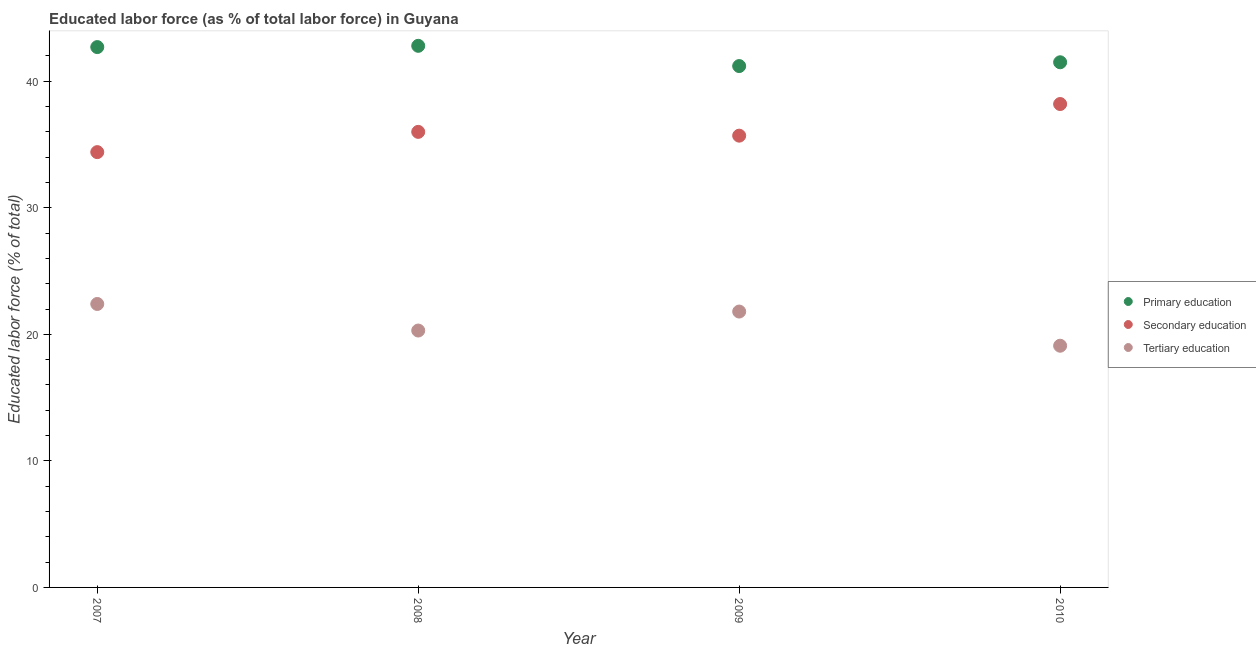What is the percentage of labor force who received secondary education in 2010?
Keep it short and to the point. 38.2. Across all years, what is the maximum percentage of labor force who received primary education?
Offer a terse response. 42.8. Across all years, what is the minimum percentage of labor force who received secondary education?
Provide a short and direct response. 34.4. In which year was the percentage of labor force who received secondary education minimum?
Offer a terse response. 2007. What is the total percentage of labor force who received primary education in the graph?
Your answer should be compact. 168.2. What is the difference between the percentage of labor force who received primary education in 2007 and that in 2010?
Your answer should be very brief. 1.2. What is the average percentage of labor force who received tertiary education per year?
Ensure brevity in your answer.  20.9. In the year 2009, what is the difference between the percentage of labor force who received tertiary education and percentage of labor force who received secondary education?
Your answer should be compact. -13.9. In how many years, is the percentage of labor force who received tertiary education greater than 14 %?
Your answer should be very brief. 4. What is the ratio of the percentage of labor force who received secondary education in 2008 to that in 2010?
Offer a very short reply. 0.94. Is the difference between the percentage of labor force who received secondary education in 2008 and 2009 greater than the difference between the percentage of labor force who received primary education in 2008 and 2009?
Offer a terse response. No. What is the difference between the highest and the second highest percentage of labor force who received primary education?
Your response must be concise. 0.1. What is the difference between the highest and the lowest percentage of labor force who received secondary education?
Offer a very short reply. 3.8. Is the sum of the percentage of labor force who received primary education in 2008 and 2010 greater than the maximum percentage of labor force who received tertiary education across all years?
Your answer should be very brief. Yes. Is it the case that in every year, the sum of the percentage of labor force who received primary education and percentage of labor force who received secondary education is greater than the percentage of labor force who received tertiary education?
Provide a succinct answer. Yes. Is the percentage of labor force who received primary education strictly greater than the percentage of labor force who received tertiary education over the years?
Make the answer very short. Yes. How many dotlines are there?
Ensure brevity in your answer.  3. How many years are there in the graph?
Keep it short and to the point. 4. What is the difference between two consecutive major ticks on the Y-axis?
Ensure brevity in your answer.  10. How are the legend labels stacked?
Ensure brevity in your answer.  Vertical. What is the title of the graph?
Your response must be concise. Educated labor force (as % of total labor force) in Guyana. What is the label or title of the X-axis?
Provide a succinct answer. Year. What is the label or title of the Y-axis?
Provide a short and direct response. Educated labor force (% of total). What is the Educated labor force (% of total) in Primary education in 2007?
Your answer should be very brief. 42.7. What is the Educated labor force (% of total) in Secondary education in 2007?
Offer a terse response. 34.4. What is the Educated labor force (% of total) in Tertiary education in 2007?
Give a very brief answer. 22.4. What is the Educated labor force (% of total) in Primary education in 2008?
Your answer should be compact. 42.8. What is the Educated labor force (% of total) of Secondary education in 2008?
Provide a short and direct response. 36. What is the Educated labor force (% of total) in Tertiary education in 2008?
Ensure brevity in your answer.  20.3. What is the Educated labor force (% of total) of Primary education in 2009?
Your answer should be compact. 41.2. What is the Educated labor force (% of total) in Secondary education in 2009?
Offer a terse response. 35.7. What is the Educated labor force (% of total) of Tertiary education in 2009?
Provide a short and direct response. 21.8. What is the Educated labor force (% of total) of Primary education in 2010?
Offer a very short reply. 41.5. What is the Educated labor force (% of total) of Secondary education in 2010?
Your answer should be compact. 38.2. What is the Educated labor force (% of total) in Tertiary education in 2010?
Keep it short and to the point. 19.1. Across all years, what is the maximum Educated labor force (% of total) of Primary education?
Ensure brevity in your answer.  42.8. Across all years, what is the maximum Educated labor force (% of total) in Secondary education?
Offer a terse response. 38.2. Across all years, what is the maximum Educated labor force (% of total) in Tertiary education?
Offer a terse response. 22.4. Across all years, what is the minimum Educated labor force (% of total) in Primary education?
Offer a very short reply. 41.2. Across all years, what is the minimum Educated labor force (% of total) in Secondary education?
Offer a terse response. 34.4. Across all years, what is the minimum Educated labor force (% of total) in Tertiary education?
Your response must be concise. 19.1. What is the total Educated labor force (% of total) of Primary education in the graph?
Your answer should be compact. 168.2. What is the total Educated labor force (% of total) of Secondary education in the graph?
Provide a succinct answer. 144.3. What is the total Educated labor force (% of total) of Tertiary education in the graph?
Provide a succinct answer. 83.6. What is the difference between the Educated labor force (% of total) in Primary education in 2007 and that in 2008?
Offer a very short reply. -0.1. What is the difference between the Educated labor force (% of total) of Secondary education in 2007 and that in 2008?
Give a very brief answer. -1.6. What is the difference between the Educated labor force (% of total) in Tertiary education in 2007 and that in 2008?
Your answer should be compact. 2.1. What is the difference between the Educated labor force (% of total) of Primary education in 2007 and that in 2009?
Provide a succinct answer. 1.5. What is the difference between the Educated labor force (% of total) of Tertiary education in 2007 and that in 2009?
Give a very brief answer. 0.6. What is the difference between the Educated labor force (% of total) of Primary education in 2007 and that in 2010?
Keep it short and to the point. 1.2. What is the difference between the Educated labor force (% of total) in Tertiary education in 2007 and that in 2010?
Provide a short and direct response. 3.3. What is the difference between the Educated labor force (% of total) of Secondary education in 2008 and that in 2009?
Offer a terse response. 0.3. What is the difference between the Educated labor force (% of total) in Tertiary education in 2008 and that in 2009?
Provide a succinct answer. -1.5. What is the difference between the Educated labor force (% of total) of Primary education in 2008 and that in 2010?
Ensure brevity in your answer.  1.3. What is the difference between the Educated labor force (% of total) of Secondary education in 2008 and that in 2010?
Keep it short and to the point. -2.2. What is the difference between the Educated labor force (% of total) of Tertiary education in 2008 and that in 2010?
Your answer should be very brief. 1.2. What is the difference between the Educated labor force (% of total) in Primary education in 2009 and that in 2010?
Your answer should be compact. -0.3. What is the difference between the Educated labor force (% of total) of Primary education in 2007 and the Educated labor force (% of total) of Secondary education in 2008?
Keep it short and to the point. 6.7. What is the difference between the Educated labor force (% of total) in Primary education in 2007 and the Educated labor force (% of total) in Tertiary education in 2008?
Your answer should be compact. 22.4. What is the difference between the Educated labor force (% of total) in Primary education in 2007 and the Educated labor force (% of total) in Tertiary education in 2009?
Offer a very short reply. 20.9. What is the difference between the Educated labor force (% of total) in Secondary education in 2007 and the Educated labor force (% of total) in Tertiary education in 2009?
Offer a very short reply. 12.6. What is the difference between the Educated labor force (% of total) in Primary education in 2007 and the Educated labor force (% of total) in Secondary education in 2010?
Offer a terse response. 4.5. What is the difference between the Educated labor force (% of total) of Primary education in 2007 and the Educated labor force (% of total) of Tertiary education in 2010?
Keep it short and to the point. 23.6. What is the difference between the Educated labor force (% of total) of Secondary education in 2007 and the Educated labor force (% of total) of Tertiary education in 2010?
Your answer should be compact. 15.3. What is the difference between the Educated labor force (% of total) in Primary education in 2008 and the Educated labor force (% of total) in Secondary education in 2010?
Ensure brevity in your answer.  4.6. What is the difference between the Educated labor force (% of total) of Primary education in 2008 and the Educated labor force (% of total) of Tertiary education in 2010?
Your answer should be compact. 23.7. What is the difference between the Educated labor force (% of total) of Primary education in 2009 and the Educated labor force (% of total) of Tertiary education in 2010?
Keep it short and to the point. 22.1. What is the average Educated labor force (% of total) of Primary education per year?
Keep it short and to the point. 42.05. What is the average Educated labor force (% of total) in Secondary education per year?
Give a very brief answer. 36.08. What is the average Educated labor force (% of total) in Tertiary education per year?
Keep it short and to the point. 20.9. In the year 2007, what is the difference between the Educated labor force (% of total) of Primary education and Educated labor force (% of total) of Tertiary education?
Offer a terse response. 20.3. In the year 2007, what is the difference between the Educated labor force (% of total) of Secondary education and Educated labor force (% of total) of Tertiary education?
Your answer should be very brief. 12. In the year 2008, what is the difference between the Educated labor force (% of total) of Secondary education and Educated labor force (% of total) of Tertiary education?
Offer a very short reply. 15.7. In the year 2009, what is the difference between the Educated labor force (% of total) of Primary education and Educated labor force (% of total) of Secondary education?
Your answer should be very brief. 5.5. In the year 2009, what is the difference between the Educated labor force (% of total) of Secondary education and Educated labor force (% of total) of Tertiary education?
Provide a succinct answer. 13.9. In the year 2010, what is the difference between the Educated labor force (% of total) in Primary education and Educated labor force (% of total) in Tertiary education?
Make the answer very short. 22.4. What is the ratio of the Educated labor force (% of total) of Secondary education in 2007 to that in 2008?
Offer a very short reply. 0.96. What is the ratio of the Educated labor force (% of total) in Tertiary education in 2007 to that in 2008?
Your answer should be very brief. 1.1. What is the ratio of the Educated labor force (% of total) in Primary education in 2007 to that in 2009?
Offer a very short reply. 1.04. What is the ratio of the Educated labor force (% of total) of Secondary education in 2007 to that in 2009?
Offer a very short reply. 0.96. What is the ratio of the Educated labor force (% of total) in Tertiary education in 2007 to that in 2009?
Ensure brevity in your answer.  1.03. What is the ratio of the Educated labor force (% of total) of Primary education in 2007 to that in 2010?
Provide a succinct answer. 1.03. What is the ratio of the Educated labor force (% of total) of Secondary education in 2007 to that in 2010?
Keep it short and to the point. 0.9. What is the ratio of the Educated labor force (% of total) in Tertiary education in 2007 to that in 2010?
Your answer should be very brief. 1.17. What is the ratio of the Educated labor force (% of total) of Primary education in 2008 to that in 2009?
Ensure brevity in your answer.  1.04. What is the ratio of the Educated labor force (% of total) in Secondary education in 2008 to that in 2009?
Ensure brevity in your answer.  1.01. What is the ratio of the Educated labor force (% of total) in Tertiary education in 2008 to that in 2009?
Your answer should be very brief. 0.93. What is the ratio of the Educated labor force (% of total) of Primary education in 2008 to that in 2010?
Ensure brevity in your answer.  1.03. What is the ratio of the Educated labor force (% of total) of Secondary education in 2008 to that in 2010?
Give a very brief answer. 0.94. What is the ratio of the Educated labor force (% of total) in Tertiary education in 2008 to that in 2010?
Provide a succinct answer. 1.06. What is the ratio of the Educated labor force (% of total) in Primary education in 2009 to that in 2010?
Make the answer very short. 0.99. What is the ratio of the Educated labor force (% of total) of Secondary education in 2009 to that in 2010?
Offer a very short reply. 0.93. What is the ratio of the Educated labor force (% of total) of Tertiary education in 2009 to that in 2010?
Your answer should be compact. 1.14. What is the difference between the highest and the second highest Educated labor force (% of total) in Primary education?
Give a very brief answer. 0.1. What is the difference between the highest and the second highest Educated labor force (% of total) in Tertiary education?
Provide a succinct answer. 0.6. 